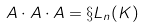Convert formula to latex. <formula><loc_0><loc_0><loc_500><loc_500>A \cdot A \cdot A = \S L _ { n } ( K )</formula> 